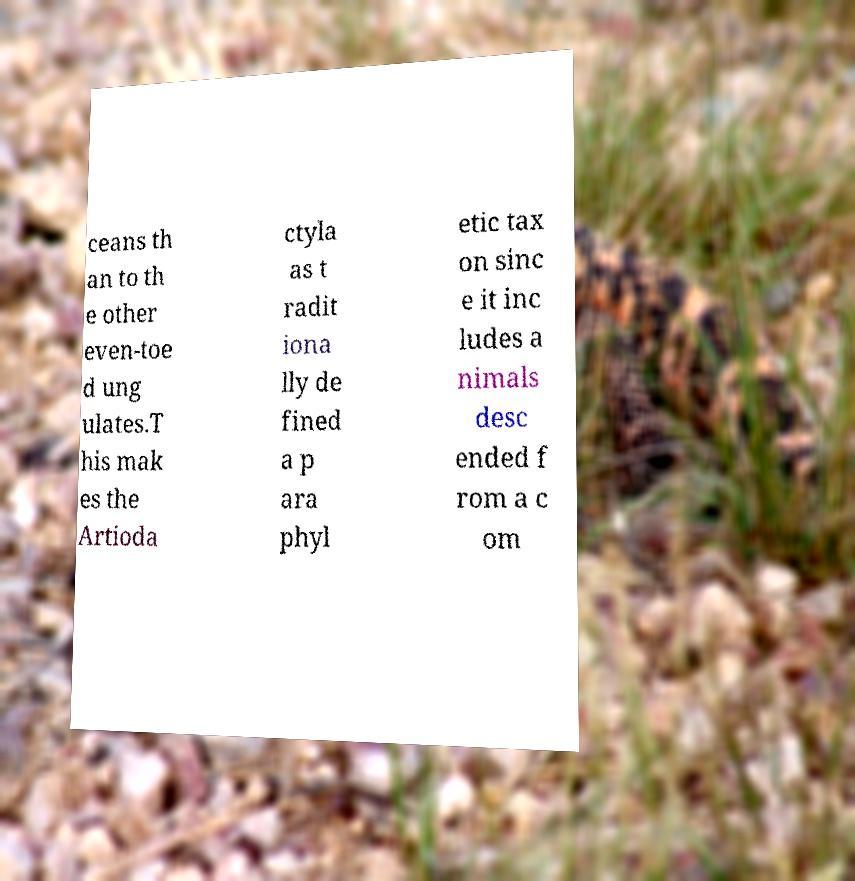Can you read and provide the text displayed in the image?This photo seems to have some interesting text. Can you extract and type it out for me? ceans th an to th e other even-toe d ung ulates.T his mak es the Artioda ctyla as t radit iona lly de fined a p ara phyl etic tax on sinc e it inc ludes a nimals desc ended f rom a c om 